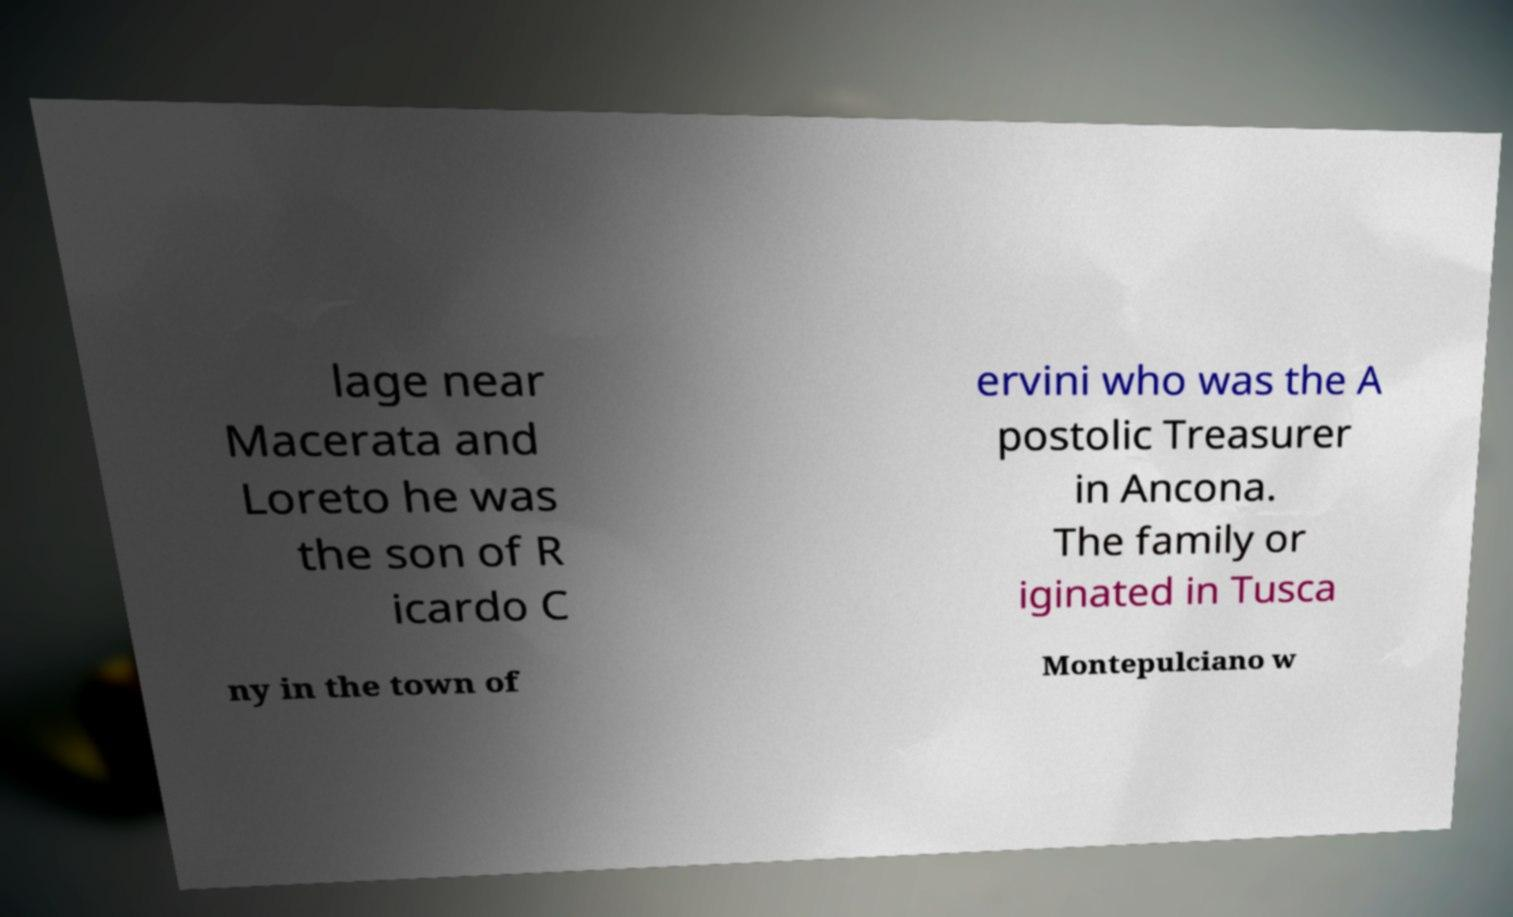What messages or text are displayed in this image? I need them in a readable, typed format. lage near Macerata and Loreto he was the son of R icardo C ervini who was the A postolic Treasurer in Ancona. The family or iginated in Tusca ny in the town of Montepulciano w 